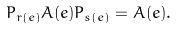Convert formula to latex. <formula><loc_0><loc_0><loc_500><loc_500>P _ { r ( e ) } A ( e ) P _ { s ( e ) } = A ( e ) .</formula> 